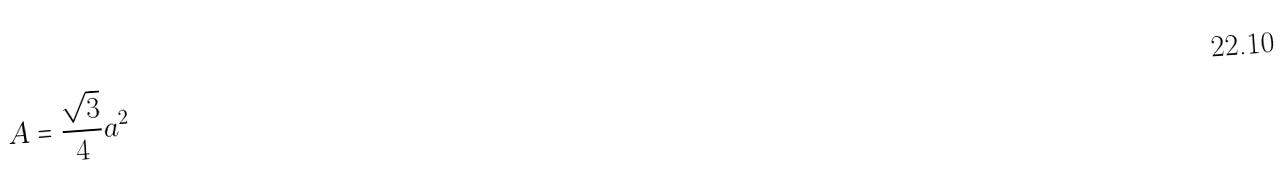Convert formula to latex. <formula><loc_0><loc_0><loc_500><loc_500>A = \frac { \sqrt { 3 } } { 4 } a ^ { 2 }</formula> 